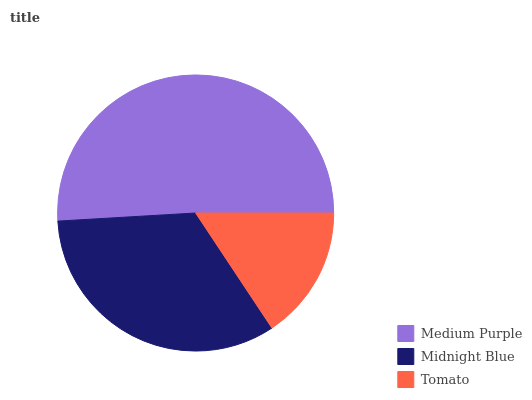Is Tomato the minimum?
Answer yes or no. Yes. Is Medium Purple the maximum?
Answer yes or no. Yes. Is Midnight Blue the minimum?
Answer yes or no. No. Is Midnight Blue the maximum?
Answer yes or no. No. Is Medium Purple greater than Midnight Blue?
Answer yes or no. Yes. Is Midnight Blue less than Medium Purple?
Answer yes or no. Yes. Is Midnight Blue greater than Medium Purple?
Answer yes or no. No. Is Medium Purple less than Midnight Blue?
Answer yes or no. No. Is Midnight Blue the high median?
Answer yes or no. Yes. Is Midnight Blue the low median?
Answer yes or no. Yes. Is Tomato the high median?
Answer yes or no. No. Is Tomato the low median?
Answer yes or no. No. 